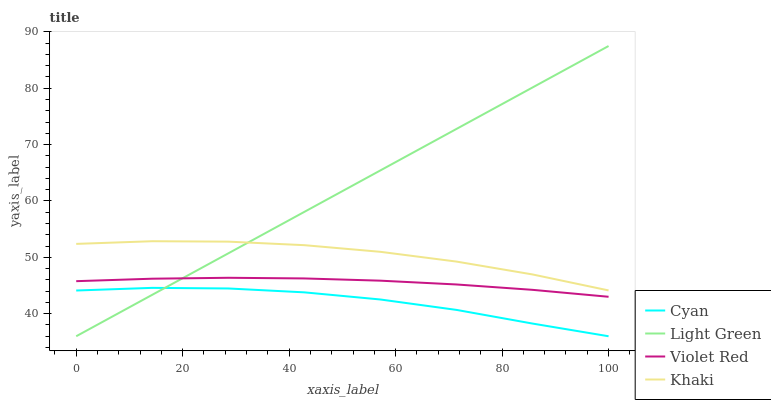Does Violet Red have the minimum area under the curve?
Answer yes or no. No. Does Violet Red have the maximum area under the curve?
Answer yes or no. No. Is Violet Red the smoothest?
Answer yes or no. No. Is Violet Red the roughest?
Answer yes or no. No. Does Violet Red have the lowest value?
Answer yes or no. No. Does Violet Red have the highest value?
Answer yes or no. No. Is Cyan less than Khaki?
Answer yes or no. Yes. Is Khaki greater than Violet Red?
Answer yes or no. Yes. Does Cyan intersect Khaki?
Answer yes or no. No. 